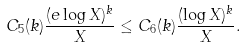<formula> <loc_0><loc_0><loc_500><loc_500>C _ { 5 } ( k ) \frac { ( e \log X ) ^ { k } } { X } \leq C _ { 6 } ( k ) \frac { ( \log X ) ^ { k } } { X } .</formula> 